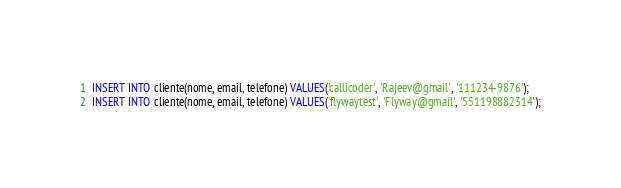<code> <loc_0><loc_0><loc_500><loc_500><_SQL_>INSERT INTO cliente(nome, email, telefone) VALUES('callicoder', 'Rajeev@gmail', '111234-9876');
INSERT INTO cliente(nome, email, telefone) VALUES('flywaytest', 'Flyway@gmail', '551198882314');</code> 